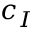Convert formula to latex. <formula><loc_0><loc_0><loc_500><loc_500>c _ { I }</formula> 